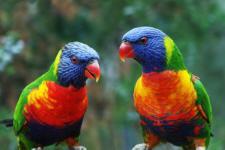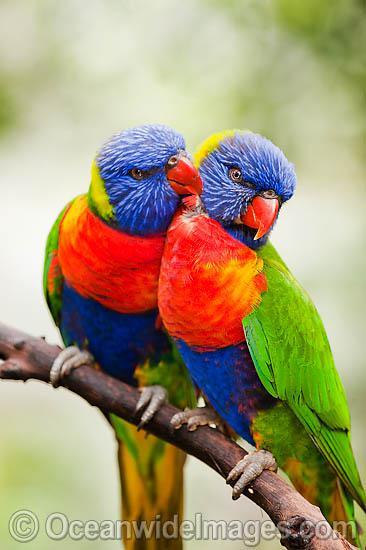The first image is the image on the left, the second image is the image on the right. Considering the images on both sides, is "A blue-headed bird with non-spread wings is perched among dark pink flowers with tendril petals." valid? Answer yes or no. No. The first image is the image on the left, the second image is the image on the right. Considering the images on both sides, is "At least one brightly colored bird perches on a branch with pink flowers." valid? Answer yes or no. No. 